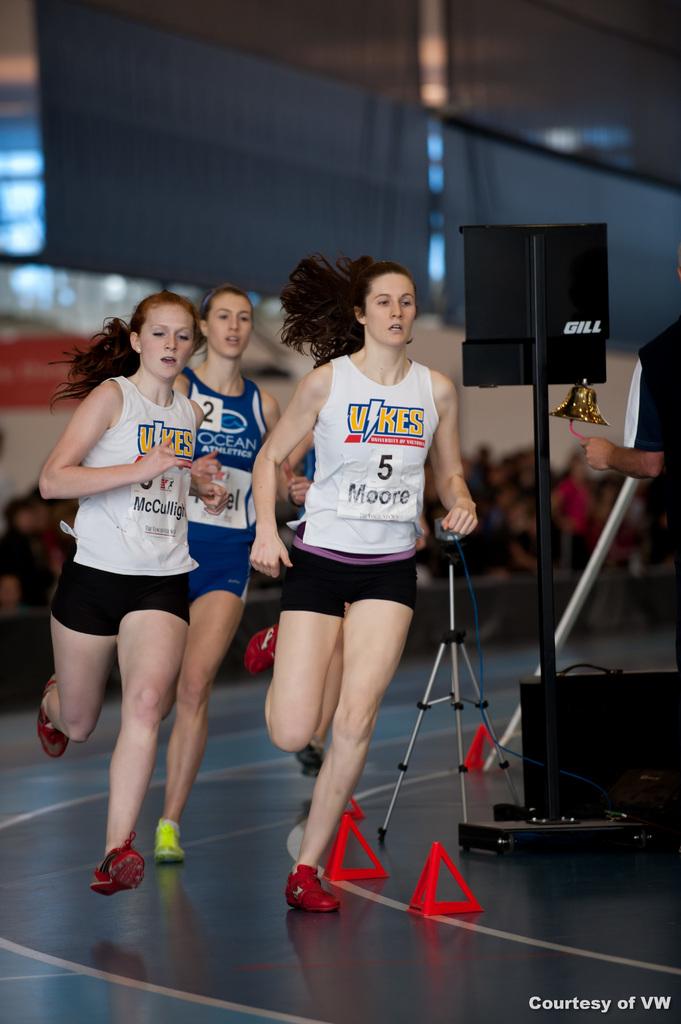What number is on the leaders shirt?
Give a very brief answer. 5. 